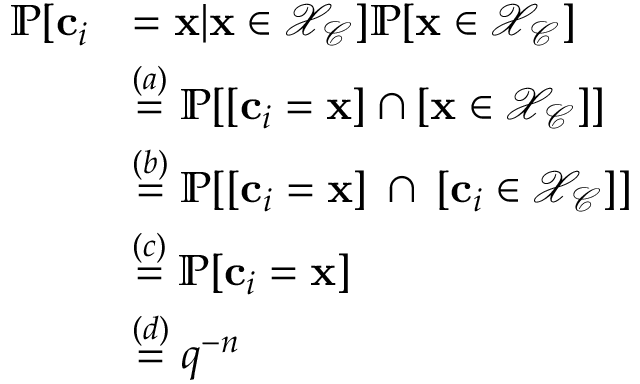Convert formula to latex. <formula><loc_0><loc_0><loc_500><loc_500>\begin{array} { r l } { \mathbb { P } [ c _ { i } } & { = x | x \in \mathcal { X } _ { \mathcal { C } } ] \mathbb { P } [ x \in \mathcal { X } _ { \mathcal { C } } ] } \\ & { \overset { ( a ) } { = } \mathbb { P } [ [ c _ { i } = x ] \cap [ x \in \mathcal { X } _ { \mathcal { C } } ] ] } \\ & { \overset { ( b ) } { = } \mathbb { P } [ [ c _ { i } = x ] \, \cap \, [ c _ { i } \in \mathcal { X } _ { \mathcal { C } } ] ] } \\ & { \overset { ( c ) } { = } \mathbb { P } [ c _ { i } = x ] } \\ & { \overset { ( d ) } { = } q ^ { - n } } \end{array}</formula> 